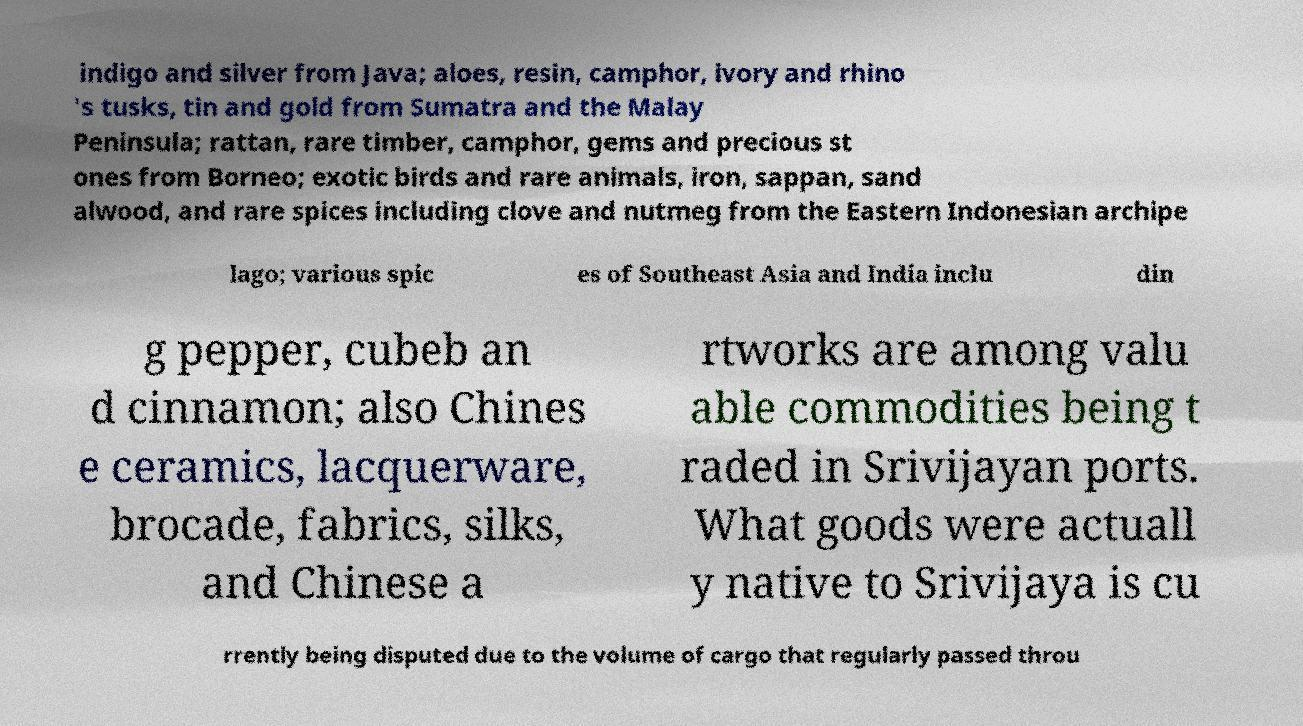For documentation purposes, I need the text within this image transcribed. Could you provide that? indigo and silver from Java; aloes, resin, camphor, ivory and rhino 's tusks, tin and gold from Sumatra and the Malay Peninsula; rattan, rare timber, camphor, gems and precious st ones from Borneo; exotic birds and rare animals, iron, sappan, sand alwood, and rare spices including clove and nutmeg from the Eastern Indonesian archipe lago; various spic es of Southeast Asia and India inclu din g pepper, cubeb an d cinnamon; also Chines e ceramics, lacquerware, brocade, fabrics, silks, and Chinese a rtworks are among valu able commodities being t raded in Srivijayan ports. What goods were actuall y native to Srivijaya is cu rrently being disputed due to the volume of cargo that regularly passed throu 